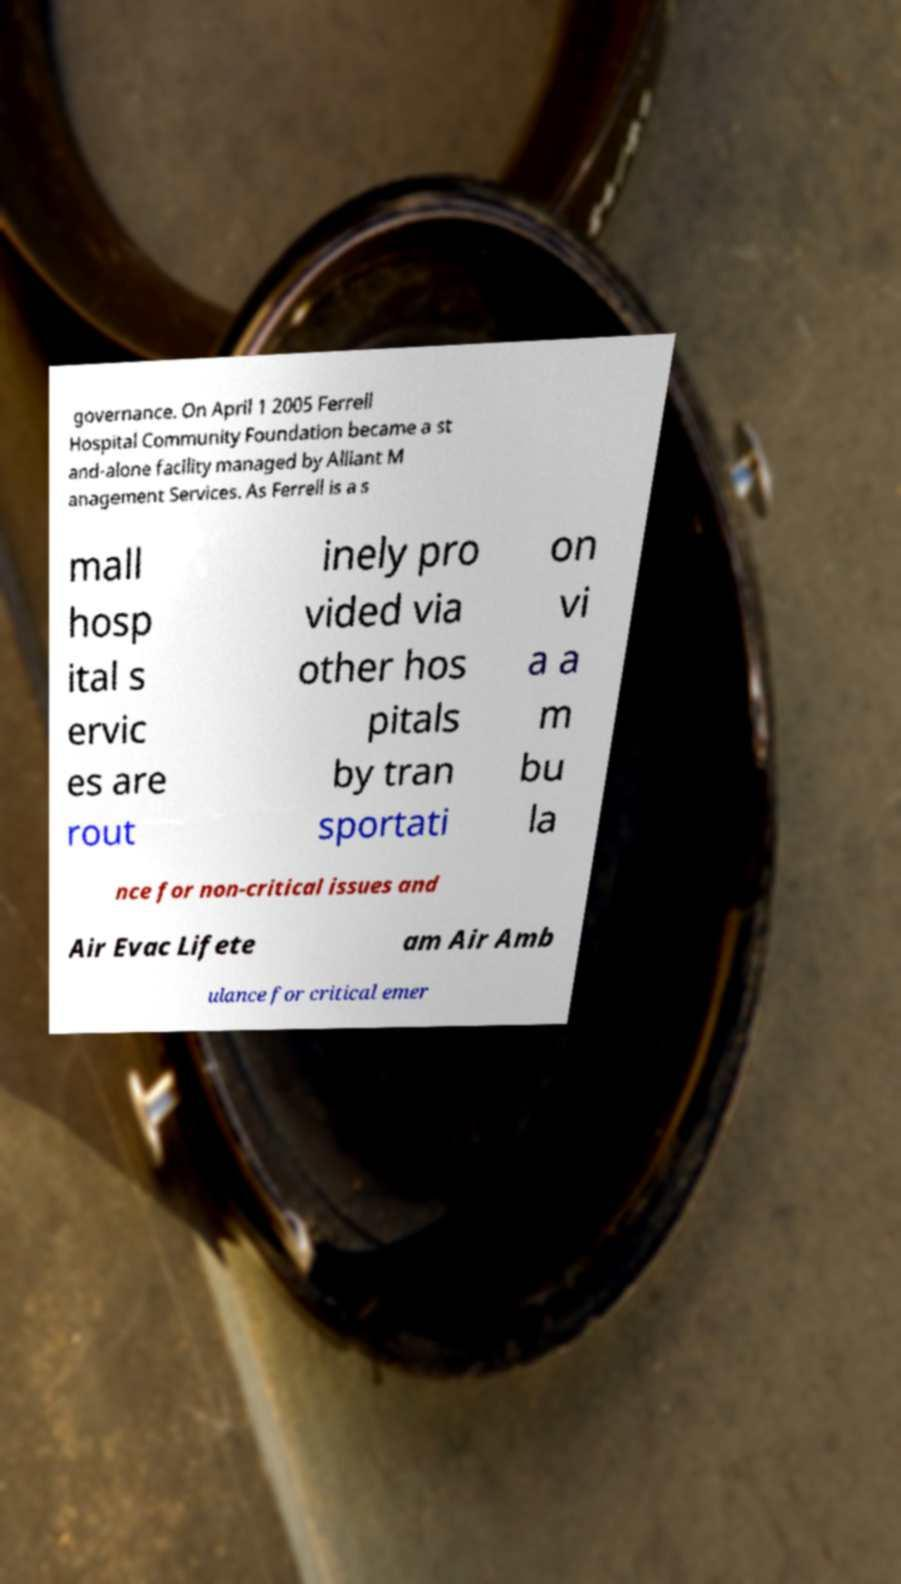What messages or text are displayed in this image? I need them in a readable, typed format. governance. On April 1 2005 Ferrell Hospital Community Foundation became a st and-alone facility managed by Alliant M anagement Services. As Ferrell is a s mall hosp ital s ervic es are rout inely pro vided via other hos pitals by tran sportati on vi a a m bu la nce for non-critical issues and Air Evac Lifete am Air Amb ulance for critical emer 